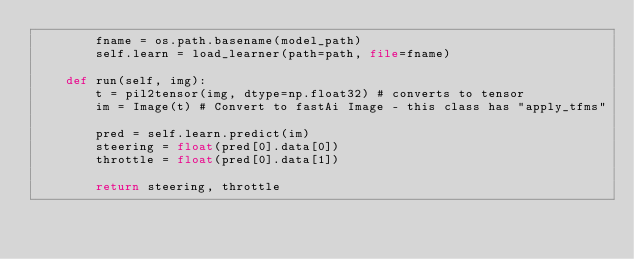Convert code to text. <code><loc_0><loc_0><loc_500><loc_500><_Python_>        fname = os.path.basename(model_path)
        self.learn = load_learner(path=path, file=fname)

    def run(self, img):
        t = pil2tensor(img, dtype=np.float32) # converts to tensor
        im = Image(t) # Convert to fastAi Image - this class has "apply_tfms"

        pred = self.learn.predict(im)
        steering = float(pred[0].data[0])
        throttle = float(pred[0].data[1])

        return steering, throttle
    </code> 